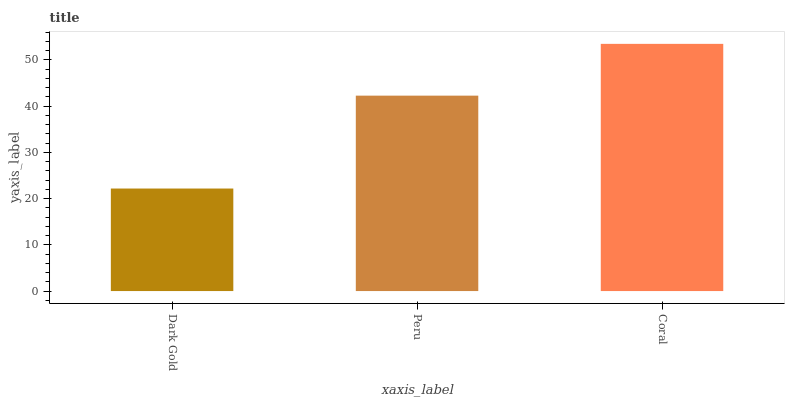Is Dark Gold the minimum?
Answer yes or no. Yes. Is Coral the maximum?
Answer yes or no. Yes. Is Peru the minimum?
Answer yes or no. No. Is Peru the maximum?
Answer yes or no. No. Is Peru greater than Dark Gold?
Answer yes or no. Yes. Is Dark Gold less than Peru?
Answer yes or no. Yes. Is Dark Gold greater than Peru?
Answer yes or no. No. Is Peru less than Dark Gold?
Answer yes or no. No. Is Peru the high median?
Answer yes or no. Yes. Is Peru the low median?
Answer yes or no. Yes. Is Coral the high median?
Answer yes or no. No. Is Coral the low median?
Answer yes or no. No. 